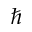<formula> <loc_0><loc_0><loc_500><loc_500>\hbar</formula> 